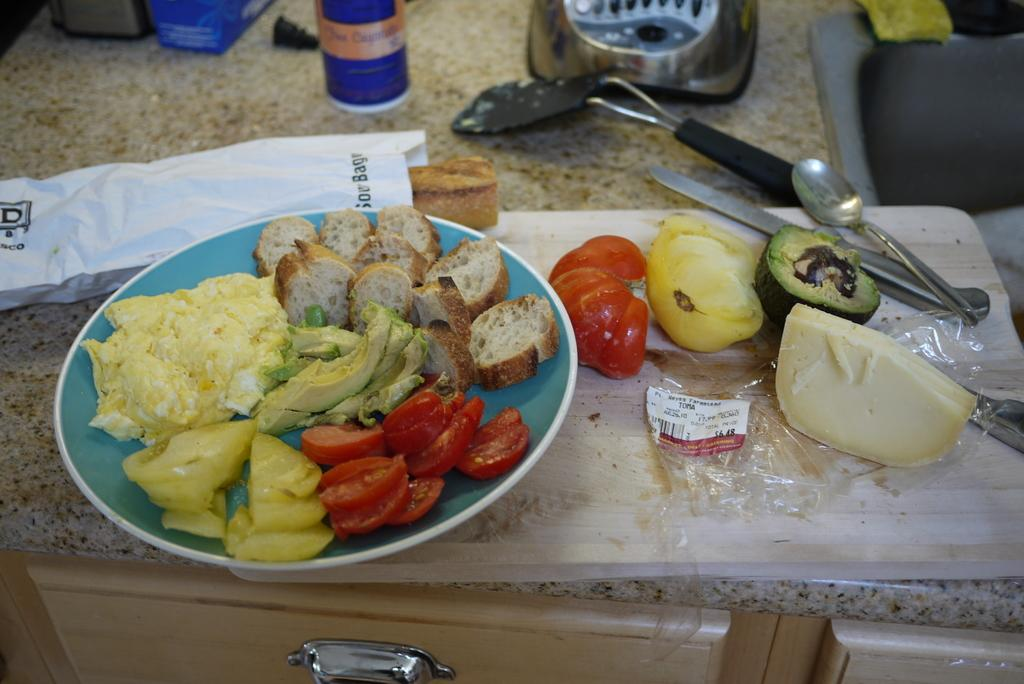What type of material is the plank in the image made of? The wooden plank in the image is made of wood. What is placed on the wooden plank? A plate, vegetables, spoons, food items, a paper, a plastic cover, a knife, and other objects are placed on the wooden plank. What can be used for eating the food items in the image? Spoons are visible in the image and can be used for eating the food items. What is the purpose of the paper in the image? The purpose of the paper in the image is not specified, but it could be used for various purposes such as wrapping or serving food. How are the food items and other objects arranged in the image? All these items are placed on a platform, which could be a table or a similar surface. What color is the orange in the image? There is no orange present in the image. How does the person in the image start the cooking process? There is no person present in the image, so it is it is not possible to determine how the cooking process might start. 